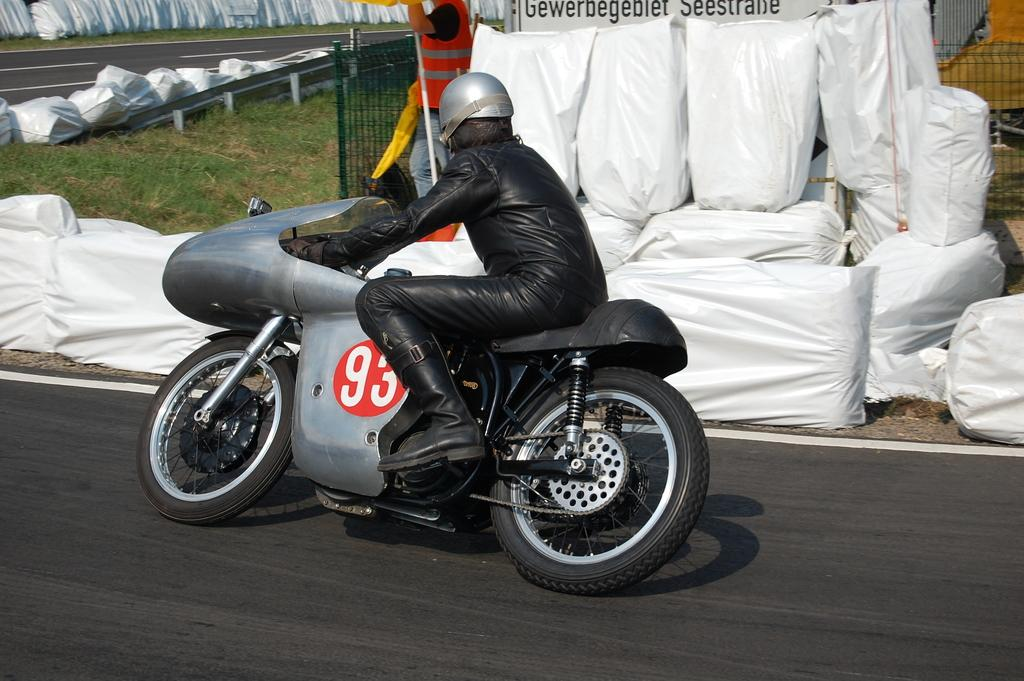What is the main subject of the image? There is a person in the image. What is the person wearing? The person is wearing a black dress. What activity is the person engaged in? The person is riding a bike. Where is the bike located? The bike is on a road. What can be seen behind the bike? There are white polypropylene sacks behind the bike. Who else is present in the image? There is a person standing behind the bike. What type of vegetation is visible in the image? Grass is visible in the image. What architectural feature can be seen in the image? There is a fence in the image. How many hot seats are available for the person to sit on in the image? There is no mention of hot seats in the image; the person is already riding a bike. Can you guide me to the nearest guide in the image? There is no guide present in the image. 